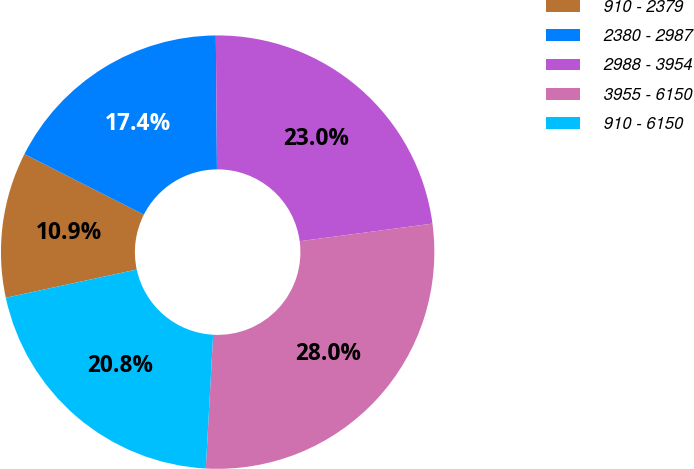Convert chart. <chart><loc_0><loc_0><loc_500><loc_500><pie_chart><fcel>910 - 2379<fcel>2380 - 2987<fcel>2988 - 3954<fcel>3955 - 6150<fcel>910 - 6150<nl><fcel>10.85%<fcel>17.39%<fcel>23.03%<fcel>27.97%<fcel>20.75%<nl></chart> 